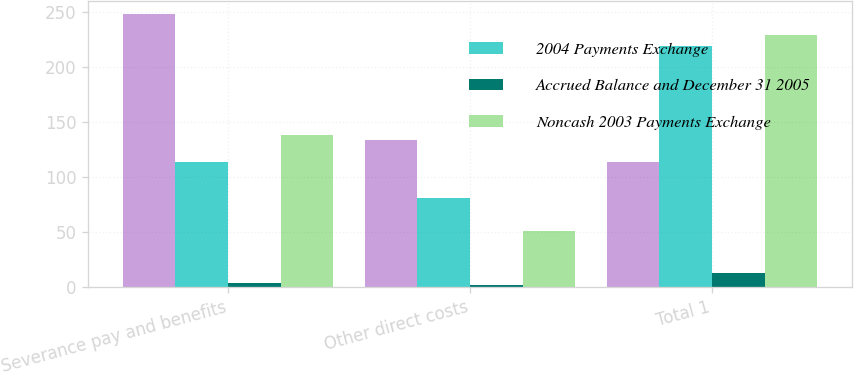Convert chart. <chart><loc_0><loc_0><loc_500><loc_500><stacked_bar_chart><ecel><fcel>Severance pay and benefits<fcel>Other direct costs<fcel>Total 1<nl><fcel>nan<fcel>248<fcel>133<fcel>113<nl><fcel>2004 Payments Exchange<fcel>113<fcel>81<fcel>219<nl><fcel>Accrued Balance and December 31 2005<fcel>3<fcel>1<fcel>12<nl><fcel>Noncash 2003 Payments Exchange<fcel>138<fcel>51<fcel>229<nl></chart> 